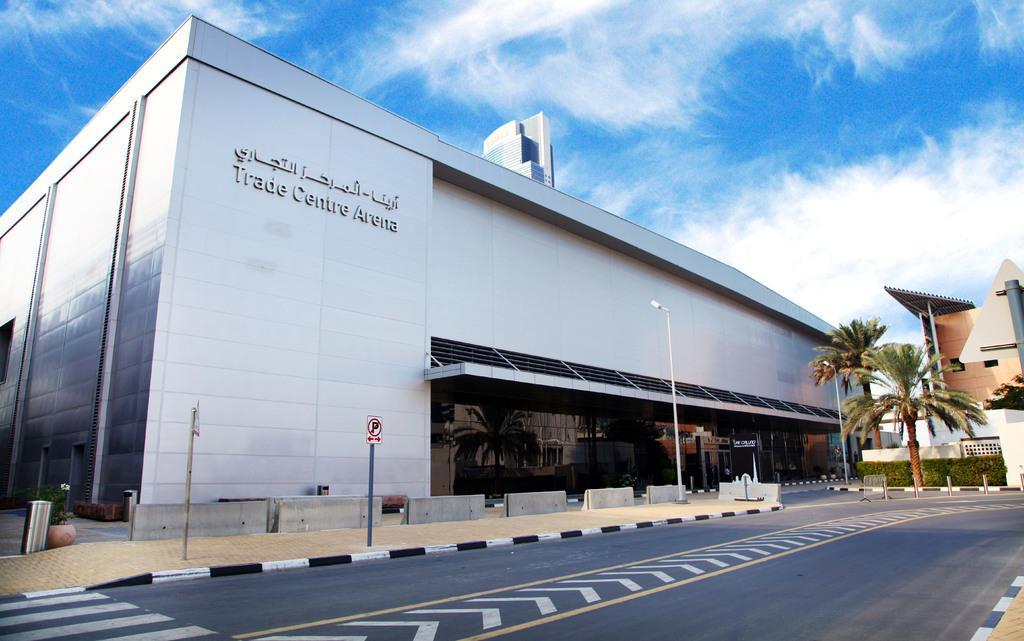In one or two sentences, can you explain what this image depicts? In this image there are buildings and trees. At the bottom there is a road and we can see poles. There is a sign board. On the left there is a bin. In the background there is sky. 